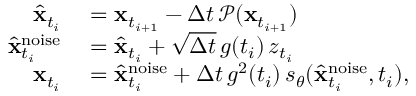Convert formula to latex. <formula><loc_0><loc_0><loc_500><loc_500>\begin{array} { r l } { \hat { x } _ { t _ { i } } } & = x _ { t _ { i + 1 } } - \Delta t \, \mathcal { P } ( x _ { t _ { i + 1 } } ) } \\ { \hat { x } _ { t _ { i } } ^ { n o i s e } } & = \hat { x } _ { t _ { i } } + \sqrt { \Delta t } \, g ( t _ { i } ) \, z _ { t _ { i } } } \\ { x _ { t _ { i } } } & = \hat { x } _ { t _ { i } } ^ { n o i s e } + \Delta t \, g ^ { 2 } ( t _ { i } ) \, s _ { \theta } ( \hat { x } _ { t _ { i } } ^ { n o i s e } , t _ { i } ) , } \end{array}</formula> 